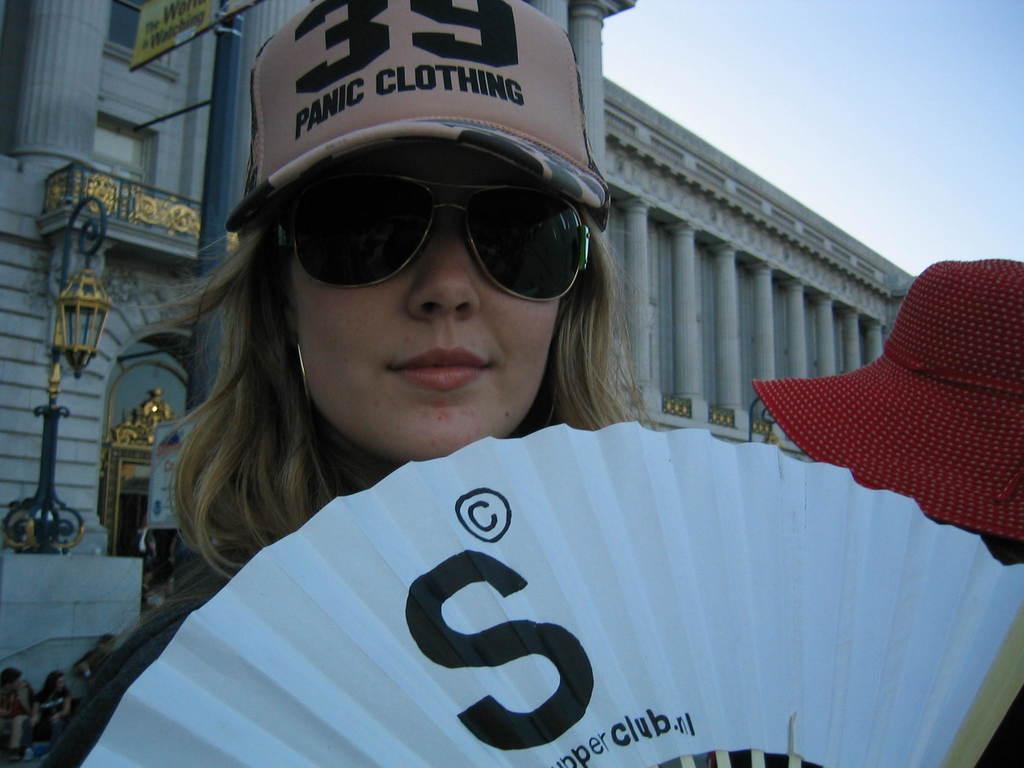Could you give a brief overview of what you see in this image? In this picture there is a woman with goggles and there is a person with red hat. At the back there is a building and there is a light on the wall and there are boards on the pole and there are group of people. At the top there is sky. 